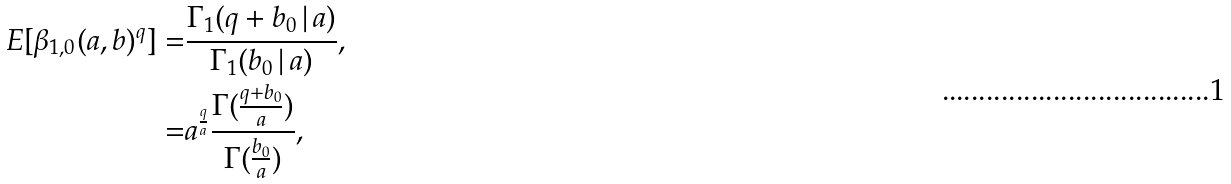Convert formula to latex. <formula><loc_0><loc_0><loc_500><loc_500>{ E } [ \beta _ { 1 , 0 } ( a , b ) ^ { q } ] = & \frac { \Gamma _ { 1 } ( q + b _ { 0 } \, | \, a ) } { \Gamma _ { 1 } ( b _ { 0 } \, | \, a ) } , \\ = & a ^ { \frac { q } { a } } \frac { \Gamma ( \frac { q + b _ { 0 } } { a } ) } { \Gamma ( \frac { b _ { 0 } } { a } ) } ,</formula> 